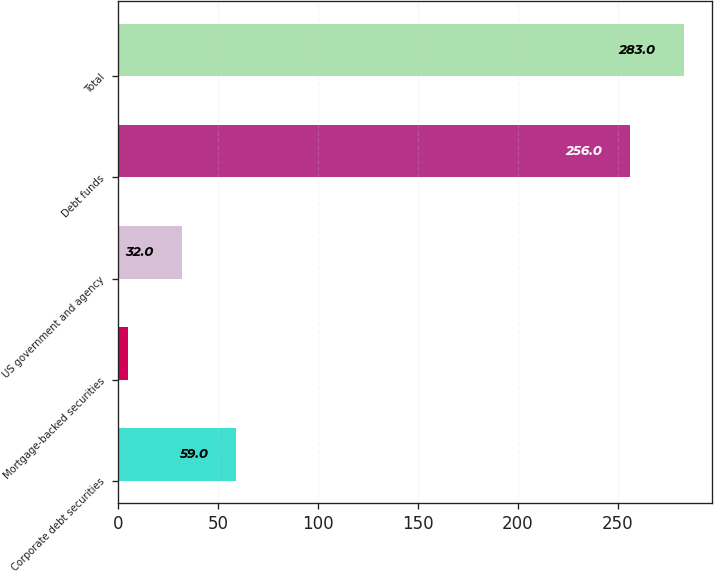<chart> <loc_0><loc_0><loc_500><loc_500><bar_chart><fcel>Corporate debt securities<fcel>Mortgage-backed securities<fcel>US government and agency<fcel>Debt funds<fcel>Total<nl><fcel>59<fcel>5<fcel>32<fcel>256<fcel>283<nl></chart> 